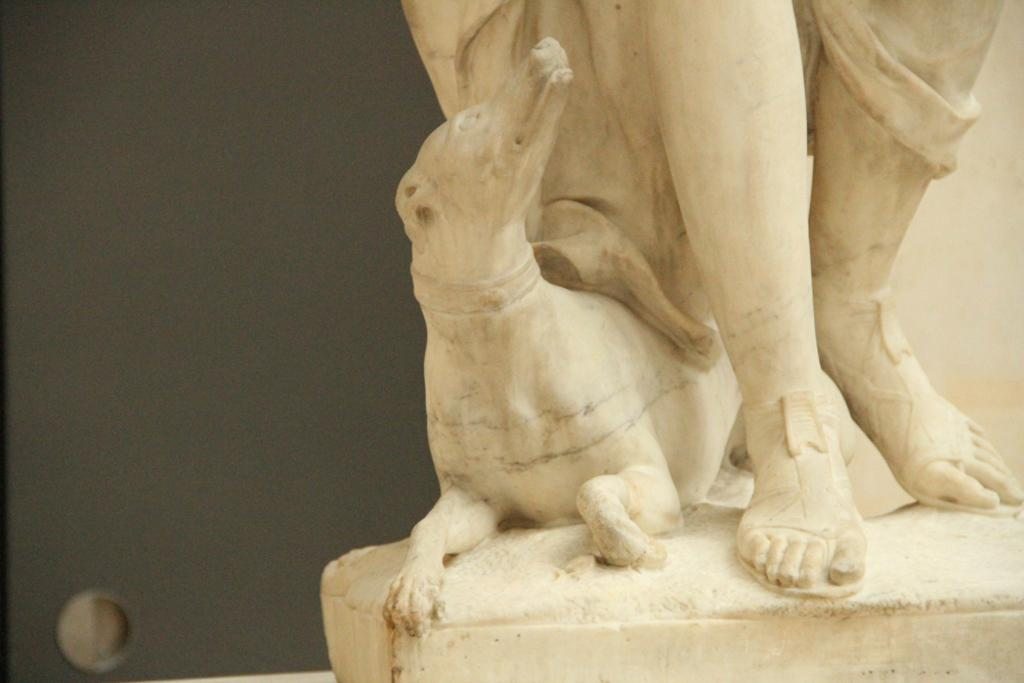What type of sculptures can be seen in the image? There is a sculpture of a person and a sculpture of an animal in the image. Can you describe the object visible in the background of the image? Unfortunately, the provided facts do not give any information about the object in the background. What is the primary focus of the image? The primary focus of the image is the sculptures, specifically the sculpture of a person and the sculpture of an animal. What type of toothpaste is being used to punish the sculpture in the image? There is no toothpaste or punishment present in the image. The image features two sculptures, one of a person and one of an animal. 